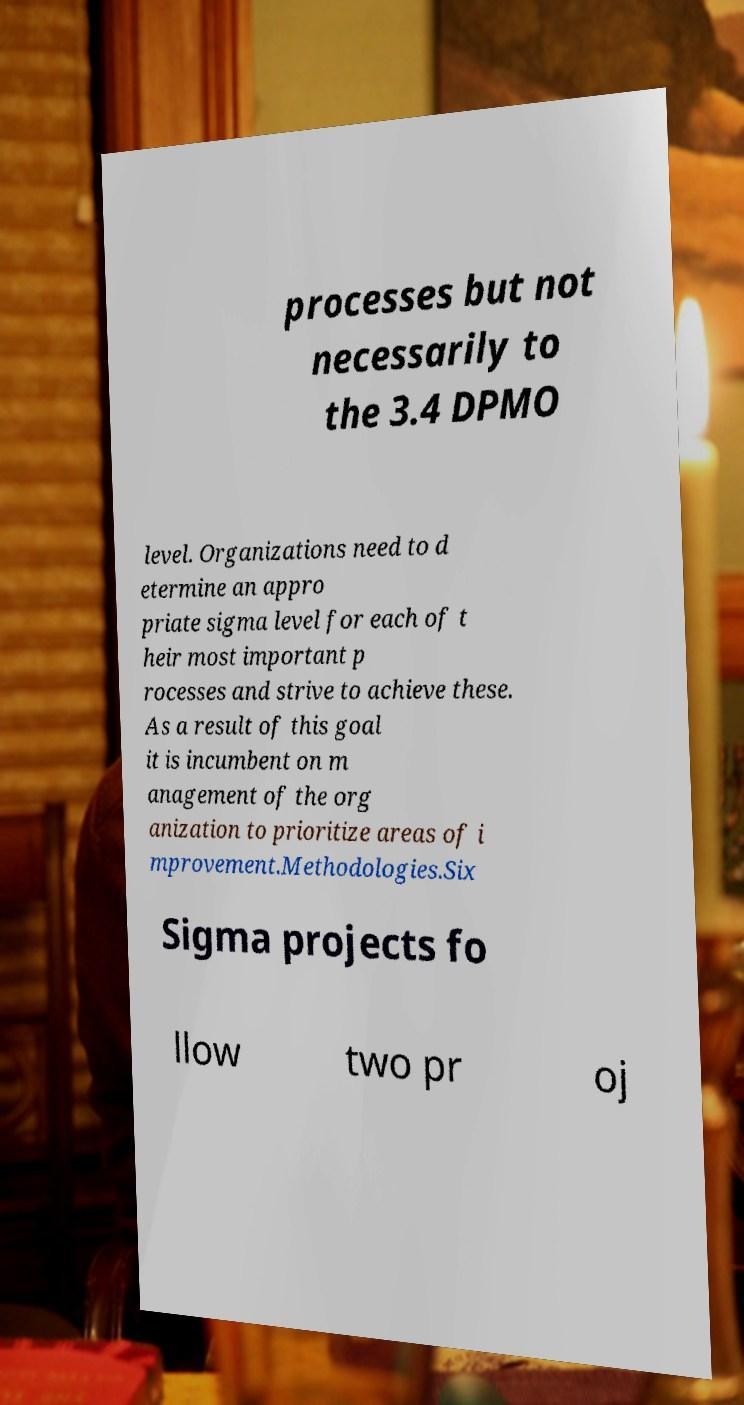Please read and relay the text visible in this image. What does it say? processes but not necessarily to the 3.4 DPMO level. Organizations need to d etermine an appro priate sigma level for each of t heir most important p rocesses and strive to achieve these. As a result of this goal it is incumbent on m anagement of the org anization to prioritize areas of i mprovement.Methodologies.Six Sigma projects fo llow two pr oj 